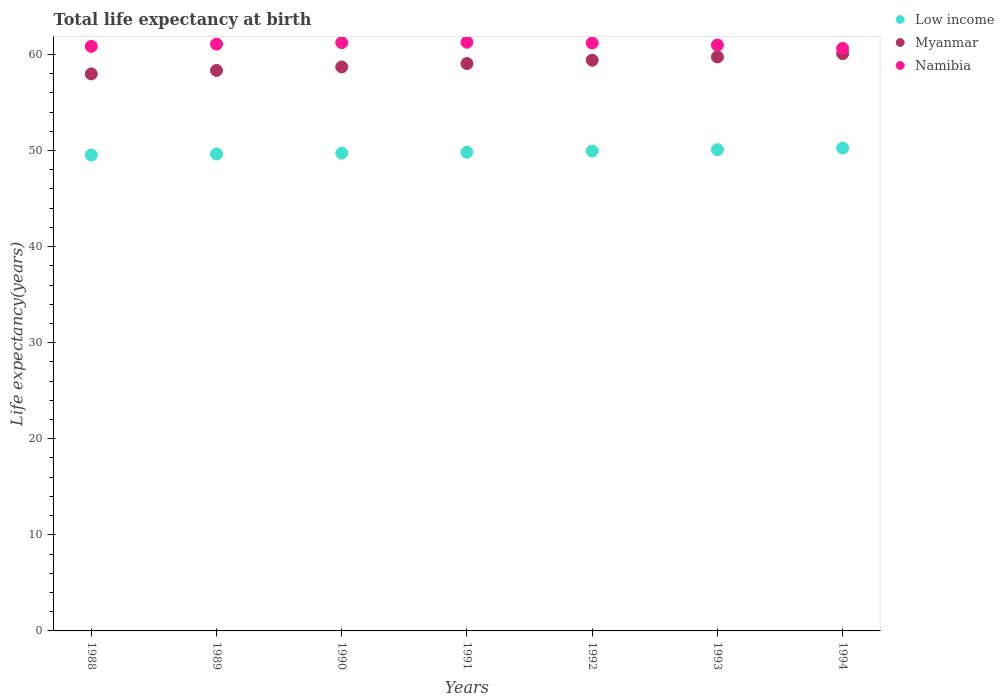How many different coloured dotlines are there?
Offer a terse response. 3. What is the life expectancy at birth in in Myanmar in 1992?
Make the answer very short. 59.4. Across all years, what is the maximum life expectancy at birth in in Myanmar?
Your response must be concise. 60.08. Across all years, what is the minimum life expectancy at birth in in Low income?
Keep it short and to the point. 49.52. In which year was the life expectancy at birth in in Namibia minimum?
Provide a succinct answer. 1994. What is the total life expectancy at birth in in Myanmar in the graph?
Your response must be concise. 413.26. What is the difference between the life expectancy at birth in in Myanmar in 1989 and that in 1990?
Offer a very short reply. -0.36. What is the difference between the life expectancy at birth in in Namibia in 1991 and the life expectancy at birth in in Myanmar in 1990?
Your answer should be very brief. 2.57. What is the average life expectancy at birth in in Myanmar per year?
Provide a short and direct response. 59.04. In the year 1988, what is the difference between the life expectancy at birth in in Namibia and life expectancy at birth in in Myanmar?
Make the answer very short. 2.86. In how many years, is the life expectancy at birth in in Low income greater than 12 years?
Provide a short and direct response. 7. What is the ratio of the life expectancy at birth in in Low income in 1991 to that in 1994?
Keep it short and to the point. 0.99. Is the difference between the life expectancy at birth in in Namibia in 1988 and 1991 greater than the difference between the life expectancy at birth in in Myanmar in 1988 and 1991?
Your answer should be very brief. Yes. What is the difference between the highest and the second highest life expectancy at birth in in Myanmar?
Provide a short and direct response. 0.34. What is the difference between the highest and the lowest life expectancy at birth in in Low income?
Offer a terse response. 0.73. Is it the case that in every year, the sum of the life expectancy at birth in in Namibia and life expectancy at birth in in Low income  is greater than the life expectancy at birth in in Myanmar?
Give a very brief answer. Yes. What is the difference between two consecutive major ticks on the Y-axis?
Provide a succinct answer. 10. Are the values on the major ticks of Y-axis written in scientific E-notation?
Make the answer very short. No. What is the title of the graph?
Offer a terse response. Total life expectancy at birth. Does "Moldova" appear as one of the legend labels in the graph?
Your response must be concise. No. What is the label or title of the Y-axis?
Provide a short and direct response. Life expectancy(years). What is the Life expectancy(years) of Low income in 1988?
Your answer should be compact. 49.52. What is the Life expectancy(years) in Myanmar in 1988?
Provide a succinct answer. 57.97. What is the Life expectancy(years) in Namibia in 1988?
Offer a terse response. 60.84. What is the Life expectancy(years) of Low income in 1989?
Keep it short and to the point. 49.64. What is the Life expectancy(years) in Myanmar in 1989?
Give a very brief answer. 58.34. What is the Life expectancy(years) of Namibia in 1989?
Your answer should be very brief. 61.07. What is the Life expectancy(years) in Low income in 1990?
Make the answer very short. 49.73. What is the Life expectancy(years) of Myanmar in 1990?
Keep it short and to the point. 58.69. What is the Life expectancy(years) in Namibia in 1990?
Your answer should be compact. 61.22. What is the Life expectancy(years) in Low income in 1991?
Your response must be concise. 49.82. What is the Life expectancy(years) in Myanmar in 1991?
Keep it short and to the point. 59.05. What is the Life expectancy(years) of Namibia in 1991?
Provide a succinct answer. 61.27. What is the Life expectancy(years) in Low income in 1992?
Ensure brevity in your answer.  49.94. What is the Life expectancy(years) of Myanmar in 1992?
Keep it short and to the point. 59.4. What is the Life expectancy(years) in Namibia in 1992?
Offer a very short reply. 61.19. What is the Life expectancy(years) of Low income in 1993?
Provide a short and direct response. 50.09. What is the Life expectancy(years) of Myanmar in 1993?
Keep it short and to the point. 59.74. What is the Life expectancy(years) in Namibia in 1993?
Make the answer very short. 60.98. What is the Life expectancy(years) of Low income in 1994?
Make the answer very short. 50.26. What is the Life expectancy(years) in Myanmar in 1994?
Offer a very short reply. 60.08. What is the Life expectancy(years) of Namibia in 1994?
Provide a short and direct response. 60.63. Across all years, what is the maximum Life expectancy(years) in Low income?
Make the answer very short. 50.26. Across all years, what is the maximum Life expectancy(years) in Myanmar?
Ensure brevity in your answer.  60.08. Across all years, what is the maximum Life expectancy(years) of Namibia?
Your answer should be compact. 61.27. Across all years, what is the minimum Life expectancy(years) in Low income?
Offer a terse response. 49.52. Across all years, what is the minimum Life expectancy(years) of Myanmar?
Offer a terse response. 57.97. Across all years, what is the minimum Life expectancy(years) of Namibia?
Offer a terse response. 60.63. What is the total Life expectancy(years) of Low income in the graph?
Your answer should be very brief. 348.99. What is the total Life expectancy(years) of Myanmar in the graph?
Offer a very short reply. 413.26. What is the total Life expectancy(years) of Namibia in the graph?
Offer a terse response. 427.2. What is the difference between the Life expectancy(years) in Low income in 1988 and that in 1989?
Offer a very short reply. -0.11. What is the difference between the Life expectancy(years) of Myanmar in 1988 and that in 1989?
Provide a short and direct response. -0.36. What is the difference between the Life expectancy(years) of Namibia in 1988 and that in 1989?
Keep it short and to the point. -0.24. What is the difference between the Life expectancy(years) of Low income in 1988 and that in 1990?
Provide a succinct answer. -0.2. What is the difference between the Life expectancy(years) of Myanmar in 1988 and that in 1990?
Offer a very short reply. -0.72. What is the difference between the Life expectancy(years) of Namibia in 1988 and that in 1990?
Offer a terse response. -0.39. What is the difference between the Life expectancy(years) in Low income in 1988 and that in 1991?
Ensure brevity in your answer.  -0.3. What is the difference between the Life expectancy(years) of Myanmar in 1988 and that in 1991?
Offer a very short reply. -1.08. What is the difference between the Life expectancy(years) of Namibia in 1988 and that in 1991?
Offer a terse response. -0.43. What is the difference between the Life expectancy(years) of Low income in 1988 and that in 1992?
Offer a very short reply. -0.41. What is the difference between the Life expectancy(years) of Myanmar in 1988 and that in 1992?
Ensure brevity in your answer.  -1.42. What is the difference between the Life expectancy(years) of Namibia in 1988 and that in 1992?
Keep it short and to the point. -0.35. What is the difference between the Life expectancy(years) in Low income in 1988 and that in 1993?
Your answer should be compact. -0.56. What is the difference between the Life expectancy(years) of Myanmar in 1988 and that in 1993?
Make the answer very short. -1.77. What is the difference between the Life expectancy(years) of Namibia in 1988 and that in 1993?
Your response must be concise. -0.14. What is the difference between the Life expectancy(years) in Low income in 1988 and that in 1994?
Ensure brevity in your answer.  -0.73. What is the difference between the Life expectancy(years) in Myanmar in 1988 and that in 1994?
Your response must be concise. -2.1. What is the difference between the Life expectancy(years) in Namibia in 1988 and that in 1994?
Your response must be concise. 0.21. What is the difference between the Life expectancy(years) in Low income in 1989 and that in 1990?
Offer a terse response. -0.09. What is the difference between the Life expectancy(years) in Myanmar in 1989 and that in 1990?
Keep it short and to the point. -0.36. What is the difference between the Life expectancy(years) in Namibia in 1989 and that in 1990?
Your answer should be very brief. -0.15. What is the difference between the Life expectancy(years) in Low income in 1989 and that in 1991?
Ensure brevity in your answer.  -0.18. What is the difference between the Life expectancy(years) of Myanmar in 1989 and that in 1991?
Give a very brief answer. -0.71. What is the difference between the Life expectancy(years) in Namibia in 1989 and that in 1991?
Your answer should be compact. -0.2. What is the difference between the Life expectancy(years) in Low income in 1989 and that in 1992?
Keep it short and to the point. -0.3. What is the difference between the Life expectancy(years) in Myanmar in 1989 and that in 1992?
Your answer should be compact. -1.06. What is the difference between the Life expectancy(years) of Namibia in 1989 and that in 1992?
Your response must be concise. -0.12. What is the difference between the Life expectancy(years) of Low income in 1989 and that in 1993?
Give a very brief answer. -0.45. What is the difference between the Life expectancy(years) of Myanmar in 1989 and that in 1993?
Provide a succinct answer. -1.4. What is the difference between the Life expectancy(years) in Namibia in 1989 and that in 1993?
Make the answer very short. 0.1. What is the difference between the Life expectancy(years) of Low income in 1989 and that in 1994?
Your response must be concise. -0.62. What is the difference between the Life expectancy(years) of Myanmar in 1989 and that in 1994?
Ensure brevity in your answer.  -1.74. What is the difference between the Life expectancy(years) of Namibia in 1989 and that in 1994?
Your response must be concise. 0.45. What is the difference between the Life expectancy(years) of Low income in 1990 and that in 1991?
Provide a short and direct response. -0.09. What is the difference between the Life expectancy(years) of Myanmar in 1990 and that in 1991?
Provide a succinct answer. -0.35. What is the difference between the Life expectancy(years) of Namibia in 1990 and that in 1991?
Your response must be concise. -0.04. What is the difference between the Life expectancy(years) of Low income in 1990 and that in 1992?
Your answer should be very brief. -0.21. What is the difference between the Life expectancy(years) of Myanmar in 1990 and that in 1992?
Your response must be concise. -0.7. What is the difference between the Life expectancy(years) of Namibia in 1990 and that in 1992?
Provide a succinct answer. 0.04. What is the difference between the Life expectancy(years) of Low income in 1990 and that in 1993?
Keep it short and to the point. -0.36. What is the difference between the Life expectancy(years) of Myanmar in 1990 and that in 1993?
Your answer should be compact. -1.04. What is the difference between the Life expectancy(years) of Namibia in 1990 and that in 1993?
Make the answer very short. 0.25. What is the difference between the Life expectancy(years) in Low income in 1990 and that in 1994?
Give a very brief answer. -0.53. What is the difference between the Life expectancy(years) in Myanmar in 1990 and that in 1994?
Your response must be concise. -1.38. What is the difference between the Life expectancy(years) of Namibia in 1990 and that in 1994?
Provide a succinct answer. 0.6. What is the difference between the Life expectancy(years) in Low income in 1991 and that in 1992?
Your answer should be very brief. -0.12. What is the difference between the Life expectancy(years) in Myanmar in 1991 and that in 1992?
Give a very brief answer. -0.35. What is the difference between the Life expectancy(years) of Namibia in 1991 and that in 1992?
Keep it short and to the point. 0.08. What is the difference between the Life expectancy(years) of Low income in 1991 and that in 1993?
Ensure brevity in your answer.  -0.27. What is the difference between the Life expectancy(years) in Myanmar in 1991 and that in 1993?
Make the answer very short. -0.69. What is the difference between the Life expectancy(years) of Namibia in 1991 and that in 1993?
Make the answer very short. 0.29. What is the difference between the Life expectancy(years) of Low income in 1991 and that in 1994?
Ensure brevity in your answer.  -0.44. What is the difference between the Life expectancy(years) in Myanmar in 1991 and that in 1994?
Make the answer very short. -1.03. What is the difference between the Life expectancy(years) of Namibia in 1991 and that in 1994?
Give a very brief answer. 0.64. What is the difference between the Life expectancy(years) of Low income in 1992 and that in 1993?
Provide a short and direct response. -0.15. What is the difference between the Life expectancy(years) in Myanmar in 1992 and that in 1993?
Make the answer very short. -0.34. What is the difference between the Life expectancy(years) in Namibia in 1992 and that in 1993?
Your response must be concise. 0.21. What is the difference between the Life expectancy(years) of Low income in 1992 and that in 1994?
Make the answer very short. -0.32. What is the difference between the Life expectancy(years) of Myanmar in 1992 and that in 1994?
Make the answer very short. -0.68. What is the difference between the Life expectancy(years) of Namibia in 1992 and that in 1994?
Offer a very short reply. 0.56. What is the difference between the Life expectancy(years) of Low income in 1993 and that in 1994?
Offer a very short reply. -0.17. What is the difference between the Life expectancy(years) in Myanmar in 1993 and that in 1994?
Offer a terse response. -0.34. What is the difference between the Life expectancy(years) in Namibia in 1993 and that in 1994?
Your response must be concise. 0.35. What is the difference between the Life expectancy(years) in Low income in 1988 and the Life expectancy(years) in Myanmar in 1989?
Your answer should be compact. -8.81. What is the difference between the Life expectancy(years) of Low income in 1988 and the Life expectancy(years) of Namibia in 1989?
Offer a terse response. -11.55. What is the difference between the Life expectancy(years) of Myanmar in 1988 and the Life expectancy(years) of Namibia in 1989?
Provide a short and direct response. -3.1. What is the difference between the Life expectancy(years) in Low income in 1988 and the Life expectancy(years) in Myanmar in 1990?
Give a very brief answer. -9.17. What is the difference between the Life expectancy(years) in Low income in 1988 and the Life expectancy(years) in Namibia in 1990?
Provide a short and direct response. -11.7. What is the difference between the Life expectancy(years) of Myanmar in 1988 and the Life expectancy(years) of Namibia in 1990?
Make the answer very short. -3.25. What is the difference between the Life expectancy(years) in Low income in 1988 and the Life expectancy(years) in Myanmar in 1991?
Provide a short and direct response. -9.52. What is the difference between the Life expectancy(years) of Low income in 1988 and the Life expectancy(years) of Namibia in 1991?
Your response must be concise. -11.74. What is the difference between the Life expectancy(years) of Myanmar in 1988 and the Life expectancy(years) of Namibia in 1991?
Ensure brevity in your answer.  -3.3. What is the difference between the Life expectancy(years) of Low income in 1988 and the Life expectancy(years) of Myanmar in 1992?
Keep it short and to the point. -9.87. What is the difference between the Life expectancy(years) in Low income in 1988 and the Life expectancy(years) in Namibia in 1992?
Make the answer very short. -11.67. What is the difference between the Life expectancy(years) in Myanmar in 1988 and the Life expectancy(years) in Namibia in 1992?
Your response must be concise. -3.22. What is the difference between the Life expectancy(years) in Low income in 1988 and the Life expectancy(years) in Myanmar in 1993?
Your response must be concise. -10.21. What is the difference between the Life expectancy(years) of Low income in 1988 and the Life expectancy(years) of Namibia in 1993?
Offer a terse response. -11.45. What is the difference between the Life expectancy(years) of Myanmar in 1988 and the Life expectancy(years) of Namibia in 1993?
Your answer should be compact. -3. What is the difference between the Life expectancy(years) in Low income in 1988 and the Life expectancy(years) in Myanmar in 1994?
Keep it short and to the point. -10.55. What is the difference between the Life expectancy(years) of Low income in 1988 and the Life expectancy(years) of Namibia in 1994?
Your answer should be very brief. -11.1. What is the difference between the Life expectancy(years) of Myanmar in 1988 and the Life expectancy(years) of Namibia in 1994?
Your response must be concise. -2.65. What is the difference between the Life expectancy(years) of Low income in 1989 and the Life expectancy(years) of Myanmar in 1990?
Provide a short and direct response. -9.06. What is the difference between the Life expectancy(years) in Low income in 1989 and the Life expectancy(years) in Namibia in 1990?
Provide a succinct answer. -11.59. What is the difference between the Life expectancy(years) in Myanmar in 1989 and the Life expectancy(years) in Namibia in 1990?
Your response must be concise. -2.89. What is the difference between the Life expectancy(years) of Low income in 1989 and the Life expectancy(years) of Myanmar in 1991?
Keep it short and to the point. -9.41. What is the difference between the Life expectancy(years) in Low income in 1989 and the Life expectancy(years) in Namibia in 1991?
Make the answer very short. -11.63. What is the difference between the Life expectancy(years) in Myanmar in 1989 and the Life expectancy(years) in Namibia in 1991?
Provide a short and direct response. -2.93. What is the difference between the Life expectancy(years) of Low income in 1989 and the Life expectancy(years) of Myanmar in 1992?
Keep it short and to the point. -9.76. What is the difference between the Life expectancy(years) of Low income in 1989 and the Life expectancy(years) of Namibia in 1992?
Your answer should be very brief. -11.55. What is the difference between the Life expectancy(years) of Myanmar in 1989 and the Life expectancy(years) of Namibia in 1992?
Offer a very short reply. -2.85. What is the difference between the Life expectancy(years) of Low income in 1989 and the Life expectancy(years) of Myanmar in 1993?
Keep it short and to the point. -10.1. What is the difference between the Life expectancy(years) of Low income in 1989 and the Life expectancy(years) of Namibia in 1993?
Offer a very short reply. -11.34. What is the difference between the Life expectancy(years) in Myanmar in 1989 and the Life expectancy(years) in Namibia in 1993?
Your answer should be compact. -2.64. What is the difference between the Life expectancy(years) of Low income in 1989 and the Life expectancy(years) of Myanmar in 1994?
Your answer should be very brief. -10.44. What is the difference between the Life expectancy(years) of Low income in 1989 and the Life expectancy(years) of Namibia in 1994?
Keep it short and to the point. -10.99. What is the difference between the Life expectancy(years) in Myanmar in 1989 and the Life expectancy(years) in Namibia in 1994?
Your response must be concise. -2.29. What is the difference between the Life expectancy(years) in Low income in 1990 and the Life expectancy(years) in Myanmar in 1991?
Your response must be concise. -9.32. What is the difference between the Life expectancy(years) of Low income in 1990 and the Life expectancy(years) of Namibia in 1991?
Give a very brief answer. -11.54. What is the difference between the Life expectancy(years) of Myanmar in 1990 and the Life expectancy(years) of Namibia in 1991?
Your answer should be very brief. -2.58. What is the difference between the Life expectancy(years) in Low income in 1990 and the Life expectancy(years) in Myanmar in 1992?
Offer a terse response. -9.67. What is the difference between the Life expectancy(years) of Low income in 1990 and the Life expectancy(years) of Namibia in 1992?
Provide a succinct answer. -11.46. What is the difference between the Life expectancy(years) of Myanmar in 1990 and the Life expectancy(years) of Namibia in 1992?
Provide a short and direct response. -2.5. What is the difference between the Life expectancy(years) of Low income in 1990 and the Life expectancy(years) of Myanmar in 1993?
Ensure brevity in your answer.  -10.01. What is the difference between the Life expectancy(years) of Low income in 1990 and the Life expectancy(years) of Namibia in 1993?
Your answer should be compact. -11.25. What is the difference between the Life expectancy(years) of Myanmar in 1990 and the Life expectancy(years) of Namibia in 1993?
Provide a short and direct response. -2.28. What is the difference between the Life expectancy(years) of Low income in 1990 and the Life expectancy(years) of Myanmar in 1994?
Give a very brief answer. -10.35. What is the difference between the Life expectancy(years) of Low income in 1990 and the Life expectancy(years) of Namibia in 1994?
Offer a terse response. -10.9. What is the difference between the Life expectancy(years) of Myanmar in 1990 and the Life expectancy(years) of Namibia in 1994?
Offer a terse response. -1.93. What is the difference between the Life expectancy(years) of Low income in 1991 and the Life expectancy(years) of Myanmar in 1992?
Provide a short and direct response. -9.58. What is the difference between the Life expectancy(years) of Low income in 1991 and the Life expectancy(years) of Namibia in 1992?
Your answer should be very brief. -11.37. What is the difference between the Life expectancy(years) of Myanmar in 1991 and the Life expectancy(years) of Namibia in 1992?
Keep it short and to the point. -2.14. What is the difference between the Life expectancy(years) of Low income in 1991 and the Life expectancy(years) of Myanmar in 1993?
Ensure brevity in your answer.  -9.92. What is the difference between the Life expectancy(years) of Low income in 1991 and the Life expectancy(years) of Namibia in 1993?
Keep it short and to the point. -11.16. What is the difference between the Life expectancy(years) of Myanmar in 1991 and the Life expectancy(years) of Namibia in 1993?
Keep it short and to the point. -1.93. What is the difference between the Life expectancy(years) of Low income in 1991 and the Life expectancy(years) of Myanmar in 1994?
Your answer should be very brief. -10.26. What is the difference between the Life expectancy(years) of Low income in 1991 and the Life expectancy(years) of Namibia in 1994?
Offer a terse response. -10.81. What is the difference between the Life expectancy(years) of Myanmar in 1991 and the Life expectancy(years) of Namibia in 1994?
Your response must be concise. -1.58. What is the difference between the Life expectancy(years) of Low income in 1992 and the Life expectancy(years) of Myanmar in 1993?
Ensure brevity in your answer.  -9.8. What is the difference between the Life expectancy(years) of Low income in 1992 and the Life expectancy(years) of Namibia in 1993?
Your response must be concise. -11.04. What is the difference between the Life expectancy(years) of Myanmar in 1992 and the Life expectancy(years) of Namibia in 1993?
Ensure brevity in your answer.  -1.58. What is the difference between the Life expectancy(years) in Low income in 1992 and the Life expectancy(years) in Myanmar in 1994?
Your answer should be very brief. -10.14. What is the difference between the Life expectancy(years) in Low income in 1992 and the Life expectancy(years) in Namibia in 1994?
Ensure brevity in your answer.  -10.69. What is the difference between the Life expectancy(years) of Myanmar in 1992 and the Life expectancy(years) of Namibia in 1994?
Provide a succinct answer. -1.23. What is the difference between the Life expectancy(years) in Low income in 1993 and the Life expectancy(years) in Myanmar in 1994?
Your response must be concise. -9.99. What is the difference between the Life expectancy(years) of Low income in 1993 and the Life expectancy(years) of Namibia in 1994?
Offer a terse response. -10.54. What is the difference between the Life expectancy(years) of Myanmar in 1993 and the Life expectancy(years) of Namibia in 1994?
Your answer should be compact. -0.89. What is the average Life expectancy(years) in Low income per year?
Your answer should be very brief. 49.86. What is the average Life expectancy(years) in Myanmar per year?
Offer a terse response. 59.04. What is the average Life expectancy(years) of Namibia per year?
Give a very brief answer. 61.03. In the year 1988, what is the difference between the Life expectancy(years) in Low income and Life expectancy(years) in Myanmar?
Offer a very short reply. -8.45. In the year 1988, what is the difference between the Life expectancy(years) of Low income and Life expectancy(years) of Namibia?
Your answer should be compact. -11.31. In the year 1988, what is the difference between the Life expectancy(years) of Myanmar and Life expectancy(years) of Namibia?
Offer a terse response. -2.86. In the year 1989, what is the difference between the Life expectancy(years) of Low income and Life expectancy(years) of Myanmar?
Provide a succinct answer. -8.7. In the year 1989, what is the difference between the Life expectancy(years) in Low income and Life expectancy(years) in Namibia?
Offer a very short reply. -11.44. In the year 1989, what is the difference between the Life expectancy(years) of Myanmar and Life expectancy(years) of Namibia?
Your answer should be compact. -2.74. In the year 1990, what is the difference between the Life expectancy(years) in Low income and Life expectancy(years) in Myanmar?
Give a very brief answer. -8.97. In the year 1990, what is the difference between the Life expectancy(years) in Low income and Life expectancy(years) in Namibia?
Offer a very short reply. -11.5. In the year 1990, what is the difference between the Life expectancy(years) in Myanmar and Life expectancy(years) in Namibia?
Keep it short and to the point. -2.53. In the year 1991, what is the difference between the Life expectancy(years) in Low income and Life expectancy(years) in Myanmar?
Offer a terse response. -9.23. In the year 1991, what is the difference between the Life expectancy(years) of Low income and Life expectancy(years) of Namibia?
Provide a short and direct response. -11.45. In the year 1991, what is the difference between the Life expectancy(years) in Myanmar and Life expectancy(years) in Namibia?
Offer a terse response. -2.22. In the year 1992, what is the difference between the Life expectancy(years) of Low income and Life expectancy(years) of Myanmar?
Your answer should be very brief. -9.46. In the year 1992, what is the difference between the Life expectancy(years) in Low income and Life expectancy(years) in Namibia?
Ensure brevity in your answer.  -11.25. In the year 1992, what is the difference between the Life expectancy(years) of Myanmar and Life expectancy(years) of Namibia?
Offer a very short reply. -1.79. In the year 1993, what is the difference between the Life expectancy(years) in Low income and Life expectancy(years) in Myanmar?
Your answer should be compact. -9.65. In the year 1993, what is the difference between the Life expectancy(years) of Low income and Life expectancy(years) of Namibia?
Provide a succinct answer. -10.89. In the year 1993, what is the difference between the Life expectancy(years) of Myanmar and Life expectancy(years) of Namibia?
Ensure brevity in your answer.  -1.24. In the year 1994, what is the difference between the Life expectancy(years) of Low income and Life expectancy(years) of Myanmar?
Your answer should be compact. -9.82. In the year 1994, what is the difference between the Life expectancy(years) of Low income and Life expectancy(years) of Namibia?
Give a very brief answer. -10.37. In the year 1994, what is the difference between the Life expectancy(years) of Myanmar and Life expectancy(years) of Namibia?
Your answer should be very brief. -0.55. What is the ratio of the Life expectancy(years) in Low income in 1988 to that in 1989?
Give a very brief answer. 1. What is the ratio of the Life expectancy(years) in Namibia in 1988 to that in 1989?
Make the answer very short. 1. What is the ratio of the Life expectancy(years) of Low income in 1988 to that in 1990?
Your answer should be compact. 1. What is the ratio of the Life expectancy(years) of Myanmar in 1988 to that in 1990?
Your response must be concise. 0.99. What is the ratio of the Life expectancy(years) in Myanmar in 1988 to that in 1991?
Make the answer very short. 0.98. What is the ratio of the Life expectancy(years) in Namibia in 1988 to that in 1991?
Ensure brevity in your answer.  0.99. What is the ratio of the Life expectancy(years) of Low income in 1988 to that in 1992?
Offer a terse response. 0.99. What is the ratio of the Life expectancy(years) of Namibia in 1988 to that in 1992?
Your answer should be compact. 0.99. What is the ratio of the Life expectancy(years) of Myanmar in 1988 to that in 1993?
Your answer should be very brief. 0.97. What is the ratio of the Life expectancy(years) in Low income in 1988 to that in 1994?
Your answer should be very brief. 0.99. What is the ratio of the Life expectancy(years) in Myanmar in 1988 to that in 1994?
Keep it short and to the point. 0.96. What is the ratio of the Life expectancy(years) of Myanmar in 1989 to that in 1991?
Make the answer very short. 0.99. What is the ratio of the Life expectancy(years) in Namibia in 1989 to that in 1991?
Your response must be concise. 1. What is the ratio of the Life expectancy(years) of Low income in 1989 to that in 1992?
Offer a very short reply. 0.99. What is the ratio of the Life expectancy(years) of Myanmar in 1989 to that in 1992?
Your answer should be compact. 0.98. What is the ratio of the Life expectancy(years) of Myanmar in 1989 to that in 1993?
Provide a succinct answer. 0.98. What is the ratio of the Life expectancy(years) of Namibia in 1989 to that in 1993?
Keep it short and to the point. 1. What is the ratio of the Life expectancy(years) of Low income in 1989 to that in 1994?
Offer a terse response. 0.99. What is the ratio of the Life expectancy(years) in Namibia in 1989 to that in 1994?
Give a very brief answer. 1.01. What is the ratio of the Life expectancy(years) in Myanmar in 1990 to that in 1991?
Keep it short and to the point. 0.99. What is the ratio of the Life expectancy(years) of Myanmar in 1990 to that in 1992?
Offer a very short reply. 0.99. What is the ratio of the Life expectancy(years) of Low income in 1990 to that in 1993?
Your answer should be very brief. 0.99. What is the ratio of the Life expectancy(years) in Myanmar in 1990 to that in 1993?
Give a very brief answer. 0.98. What is the ratio of the Life expectancy(years) in Namibia in 1990 to that in 1993?
Your response must be concise. 1. What is the ratio of the Life expectancy(years) of Low income in 1990 to that in 1994?
Your response must be concise. 0.99. What is the ratio of the Life expectancy(years) of Namibia in 1990 to that in 1994?
Your response must be concise. 1.01. What is the ratio of the Life expectancy(years) in Low income in 1991 to that in 1992?
Ensure brevity in your answer.  1. What is the ratio of the Life expectancy(years) of Myanmar in 1991 to that in 1992?
Offer a very short reply. 0.99. What is the ratio of the Life expectancy(years) of Namibia in 1991 to that in 1992?
Your response must be concise. 1. What is the ratio of the Life expectancy(years) of Low income in 1991 to that in 1993?
Provide a succinct answer. 0.99. What is the ratio of the Life expectancy(years) in Myanmar in 1991 to that in 1993?
Ensure brevity in your answer.  0.99. What is the ratio of the Life expectancy(years) of Myanmar in 1991 to that in 1994?
Ensure brevity in your answer.  0.98. What is the ratio of the Life expectancy(years) in Namibia in 1991 to that in 1994?
Offer a very short reply. 1.01. What is the ratio of the Life expectancy(years) of Low income in 1992 to that in 1993?
Keep it short and to the point. 1. What is the ratio of the Life expectancy(years) of Namibia in 1992 to that in 1993?
Your response must be concise. 1. What is the ratio of the Life expectancy(years) in Myanmar in 1992 to that in 1994?
Your answer should be compact. 0.99. What is the ratio of the Life expectancy(years) in Namibia in 1992 to that in 1994?
Provide a succinct answer. 1.01. What is the ratio of the Life expectancy(years) of Myanmar in 1993 to that in 1994?
Keep it short and to the point. 0.99. What is the ratio of the Life expectancy(years) of Namibia in 1993 to that in 1994?
Ensure brevity in your answer.  1.01. What is the difference between the highest and the second highest Life expectancy(years) of Low income?
Offer a very short reply. 0.17. What is the difference between the highest and the second highest Life expectancy(years) of Myanmar?
Your response must be concise. 0.34. What is the difference between the highest and the second highest Life expectancy(years) in Namibia?
Make the answer very short. 0.04. What is the difference between the highest and the lowest Life expectancy(years) of Low income?
Your answer should be compact. 0.73. What is the difference between the highest and the lowest Life expectancy(years) in Myanmar?
Provide a short and direct response. 2.1. What is the difference between the highest and the lowest Life expectancy(years) of Namibia?
Give a very brief answer. 0.64. 